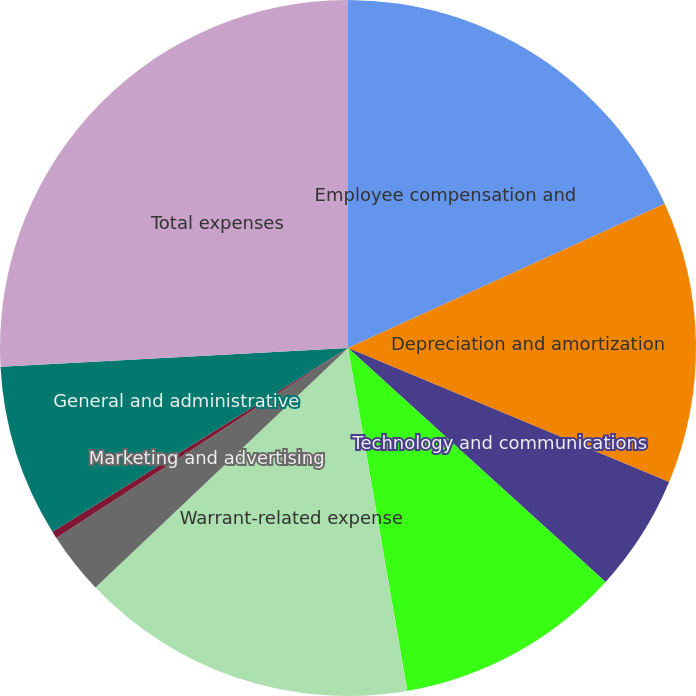Convert chart. <chart><loc_0><loc_0><loc_500><loc_500><pie_chart><fcel>Employee compensation and<fcel>Depreciation and amortization<fcel>Technology and communications<fcel>Professional and consulting<fcel>Warrant-related expense<fcel>Marketing and advertising<fcel>Moneyline revenue share<fcel>General and administrative<fcel>Total expenses<nl><fcel>18.2%<fcel>13.1%<fcel>5.44%<fcel>10.54%<fcel>15.65%<fcel>2.89%<fcel>0.34%<fcel>7.99%<fcel>25.86%<nl></chart> 